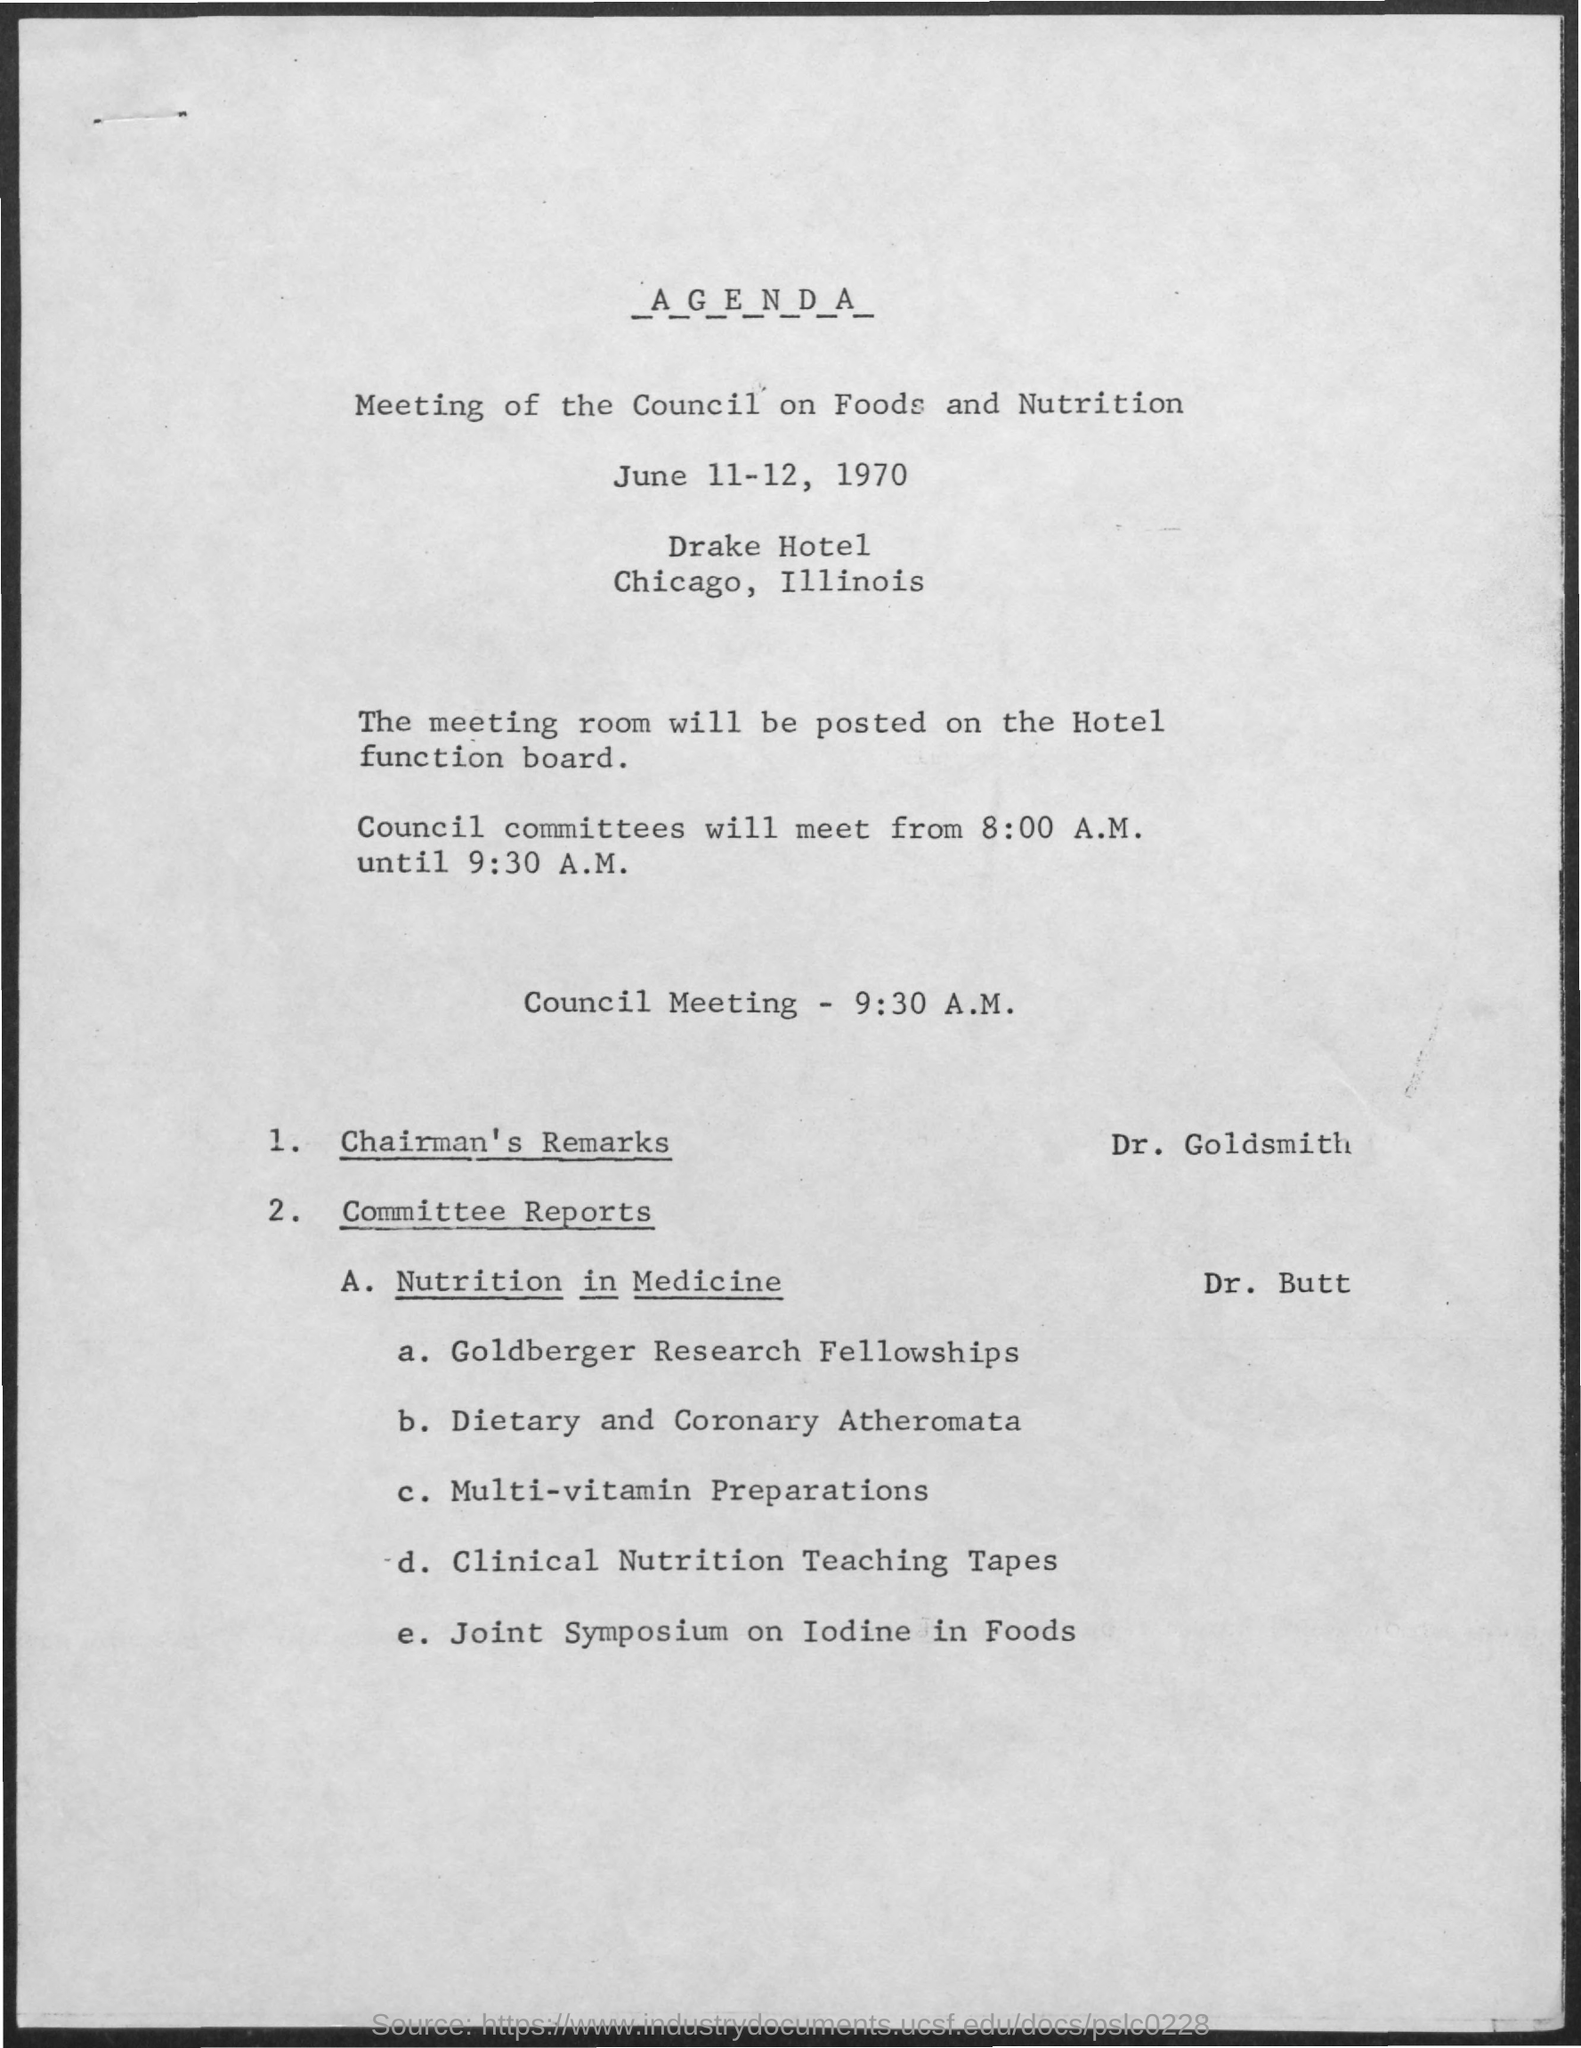When is the meeting of the council on Foods and Nutrition scheduled?
Give a very brief answer. June 11-12, 1970. Who is presenting the chairman's remarks as per the agenda?
Offer a terse response. Dr. Goldsmith. What time is the council meeting as per the agenda?
Ensure brevity in your answer.  9:30 A.M. Who is presenting the Committe reports on Nutrition in Medicine?
Offer a very short reply. Dr. Butt. 